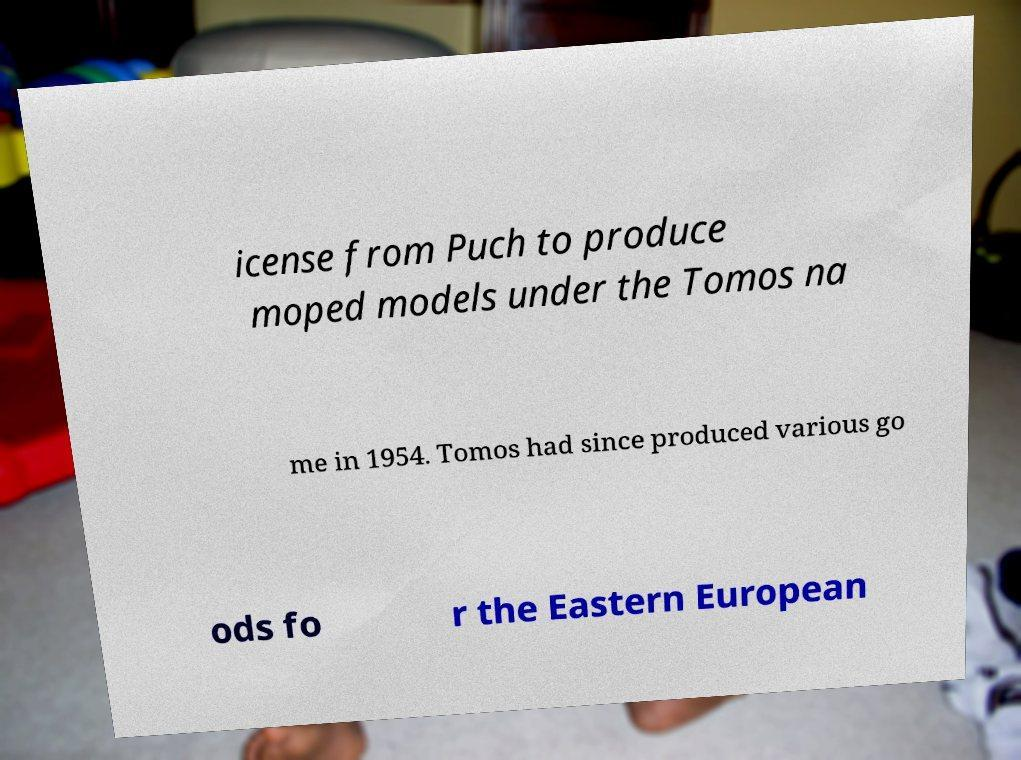Can you read and provide the text displayed in the image?This photo seems to have some interesting text. Can you extract and type it out for me? icense from Puch to produce moped models under the Tomos na me in 1954. Tomos had since produced various go ods fo r the Eastern European 